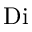Convert formula to latex. <formula><loc_0><loc_0><loc_500><loc_500>D i</formula> 